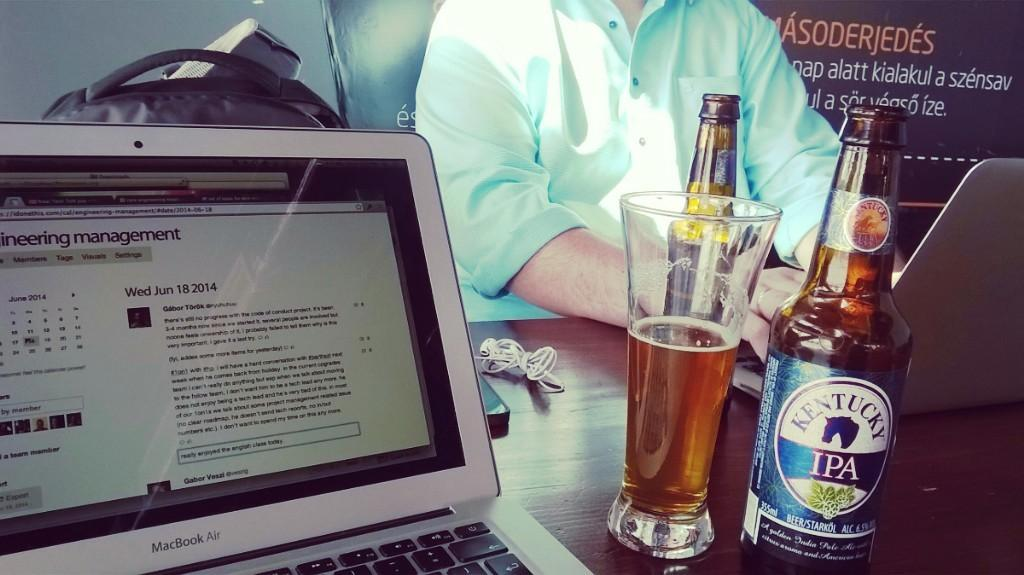<image>
Render a clear and concise summary of the photo. Man sitting by a desk with a beer bottle that says IPA on it. 